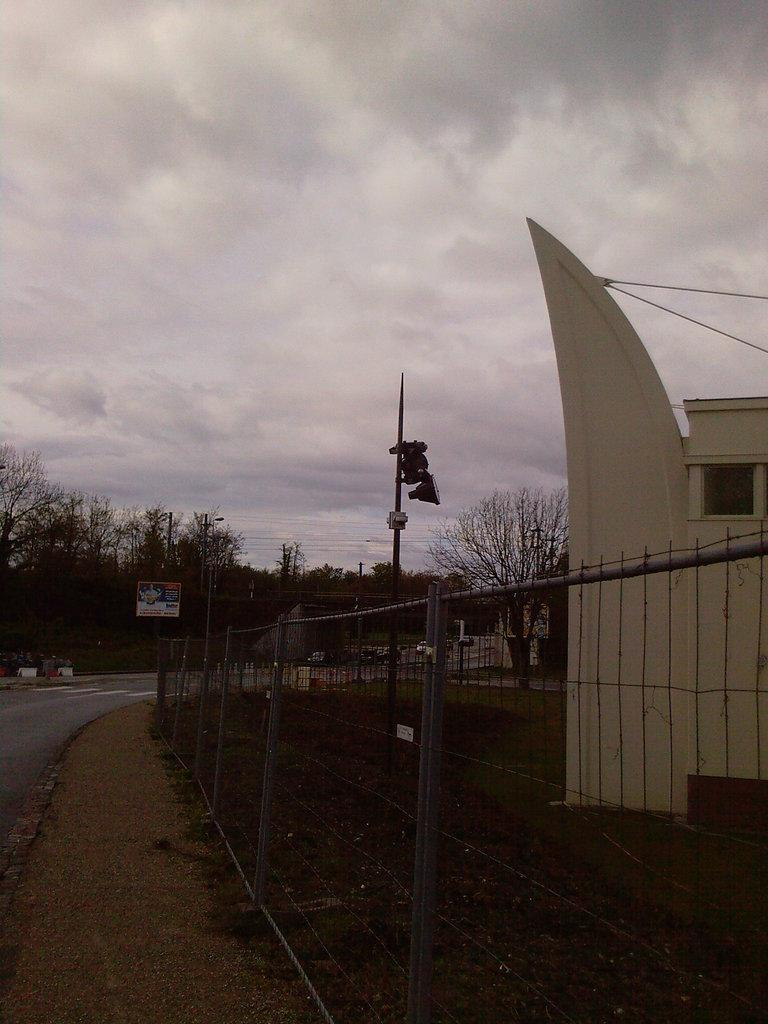What structure is located on the right side of the image? There is a building on the right side of the image. What can be seen in the center of the image? There is a fence in the center of the image. What type of vegetation is in the background of the image? There are trees in the background of the image. What else can be seen in the background of the image? There is a pole and the sky visible in the background of the image. Can you tell me how many dogs are on the island in the image? There is no island or dog present in the image. What type of insurance is being advertised on the building in the image? There is no insurance advertisement on the building in the image. 